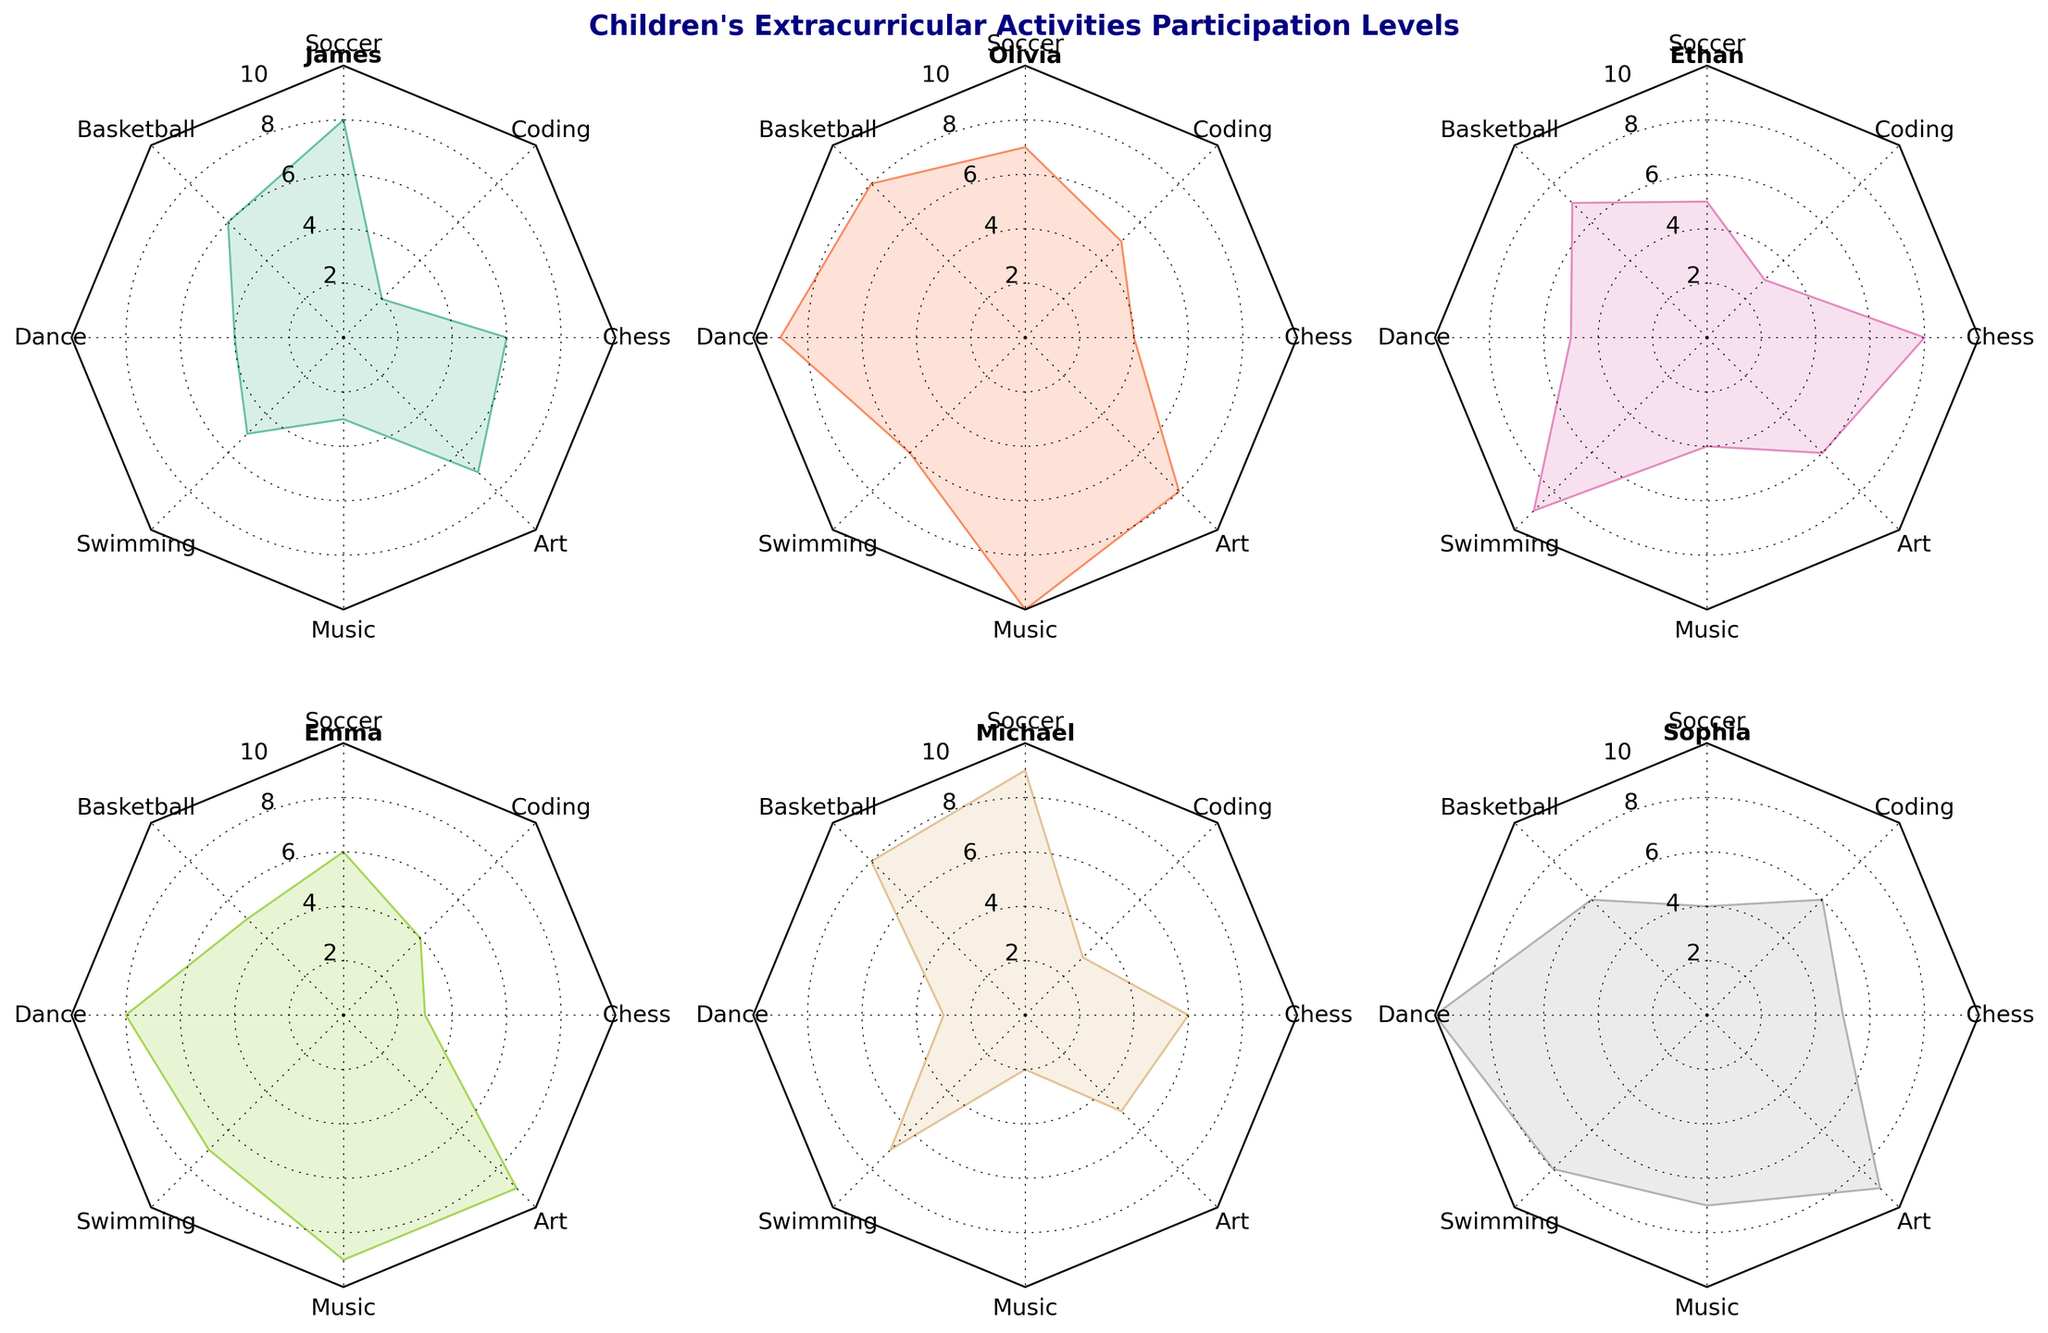What activities did the children participate in according to the figure? The titles around the radar charts each represent a different activity the children participated in. These activities are listed in the dataset as Soccer, Basketball, Dance, Swimming, Music, Art, Chess, and Coding.
Answer: Soccer, Basketball, Dance, Swimming, Music, Art, Chess, Coding Which child had the highest participation level in Dance? In the radar chart for Dance, each sector represents one of the children's participation levels. Olivia has the highest shaded area, indicating her participation level.
Answer: Olivia How does James' participation level in Coding compare to his participation in Soccer? In the radar charts for James, the value for Coding is 2 and for Soccer is 8. Comparing these, James has a higher participation level in Soccer.
Answer: Higher in Soccer Among all the children, whose overall participation seems the most balanced across different activities? By looking at the filled areas in the radar charts, the most balanced figure would have nearly equal lengths in all sectors. Sophia shows this pattern with relatively evenly distributed participation across activities.
Answer: Sophia Which activities does Olivia participate in the most and the least? Olivia’s radar chart will show the highest and lowest filled areas corresponding to different activities. The highest participation is in Music with a value of 10 and the lowest in Coding with a value of 5.
Answer: Most in Music, Least in Coding Is Ethan more involved in Chess or Coding? Referring to Ethan’s radar chart, his participation level in Chess is 8 and in Coding is 3. Hence, Ethan is more involved in Chess.
Answer: Chess What is the total participation level for Michael across all activities? Adding all the participation levels in Michael’s radar chart: Soccer (9), Basketball (8), Dance (3), Swimming (7), Music (2), Art (5), Chess (6), Coding (3): 9+8+3+7+2+5+6+3 = 43.
Answer: 43 Which activity has the most diverse range of participation levels among all children? By comparing the radar charts, we find the activity with the most significant range in filled areas among all children. Coding shows high variability with values ranging from 2 to 6.
Answer: Coding Between Soccer and Art, which activity does Emma participate more in? Looking at Emma’s radar chart, her participation level is Soccer (6) and Art (9). Therefore, Emma participates more in Art.
Answer: Art Which child is least involved in Music? Comparing the smallest values in the Music radar chart for all children, Michael has the lowest participation level with a value of 2.
Answer: Michael 